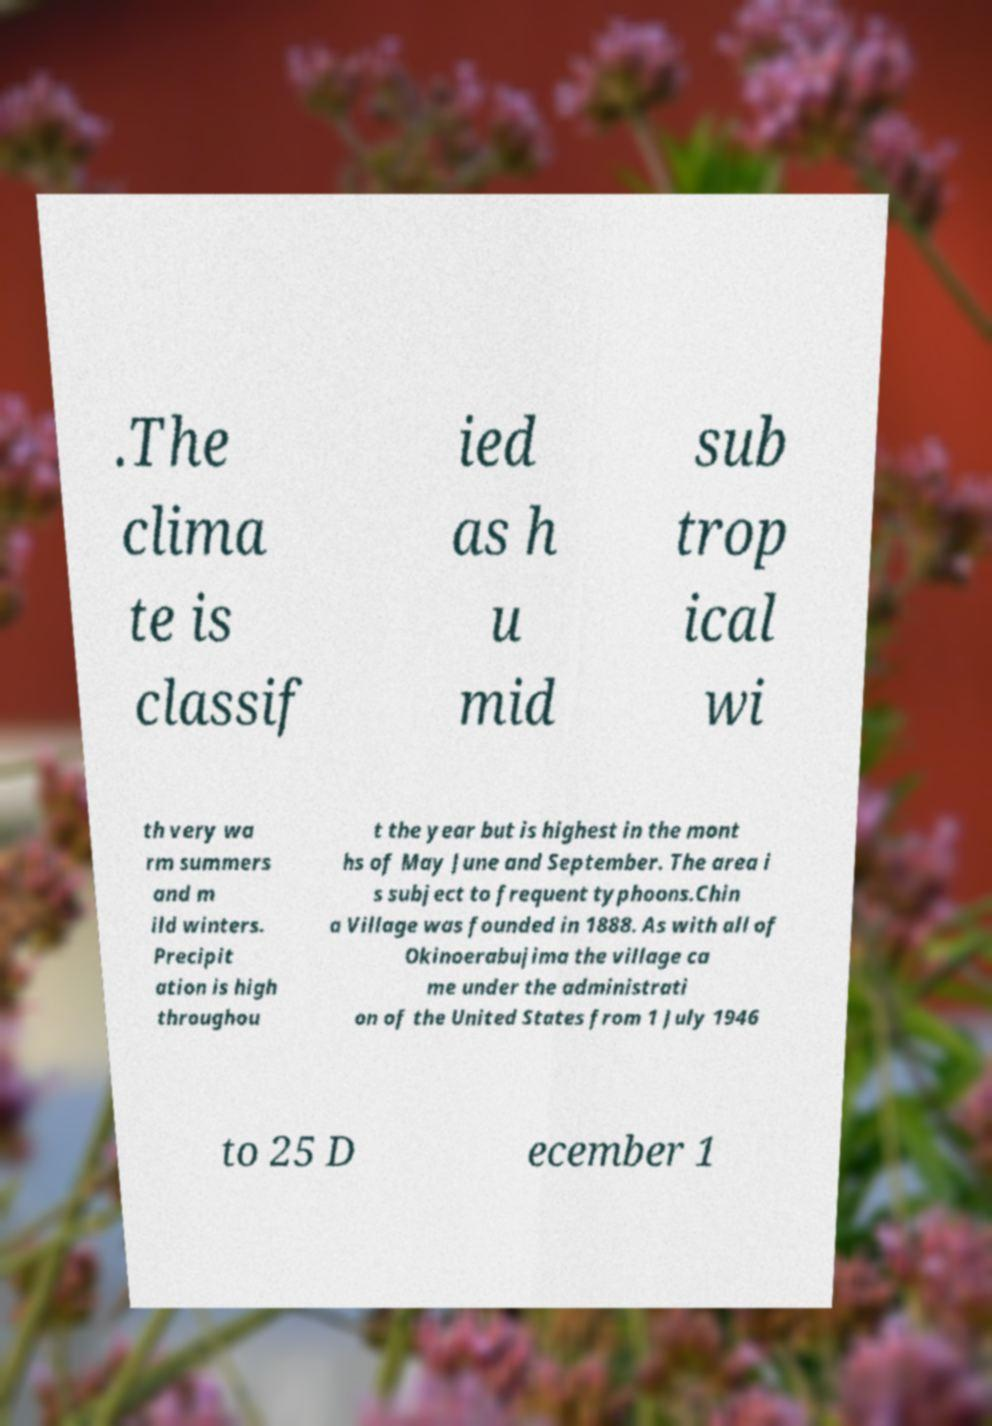Can you accurately transcribe the text from the provided image for me? .The clima te is classif ied as h u mid sub trop ical wi th very wa rm summers and m ild winters. Precipit ation is high throughou t the year but is highest in the mont hs of May June and September. The area i s subject to frequent typhoons.Chin a Village was founded in 1888. As with all of Okinoerabujima the village ca me under the administrati on of the United States from 1 July 1946 to 25 D ecember 1 